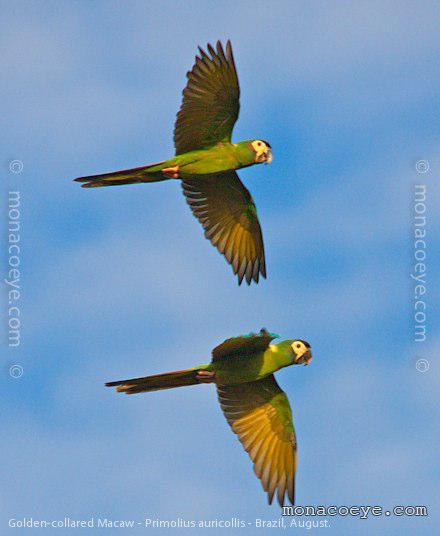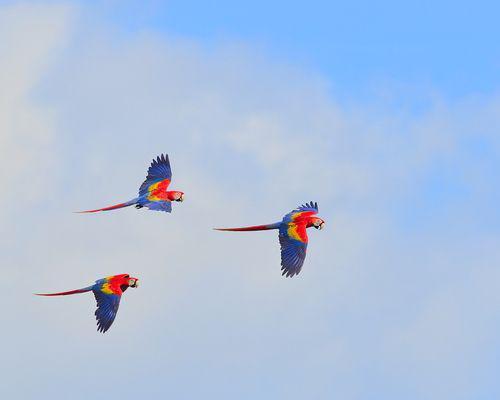The first image is the image on the left, the second image is the image on the right. Evaluate the accuracy of this statement regarding the images: "There is at least one parrot perched on something rather than in flight". Is it true? Answer yes or no. No. 